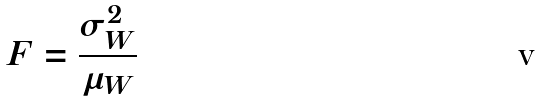Convert formula to latex. <formula><loc_0><loc_0><loc_500><loc_500>F = \frac { \sigma _ { W } ^ { 2 } } { \mu _ { W } }</formula> 